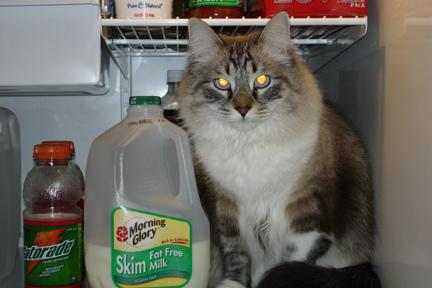What is the cat inside of?
Short answer required. Refrigerator. What two beverages are there?
Concise answer only. Gatorade and milk. Where is the cat staring at?
Write a very short answer. Camera. 